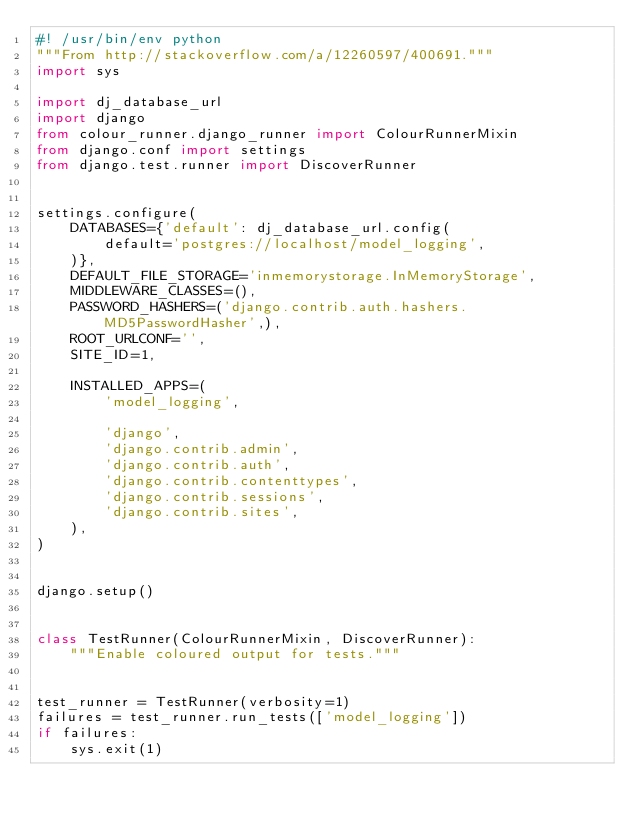Convert code to text. <code><loc_0><loc_0><loc_500><loc_500><_Python_>#! /usr/bin/env python
"""From http://stackoverflow.com/a/12260597/400691."""
import sys

import dj_database_url
import django
from colour_runner.django_runner import ColourRunnerMixin
from django.conf import settings
from django.test.runner import DiscoverRunner


settings.configure(
    DATABASES={'default': dj_database_url.config(
        default='postgres://localhost/model_logging',
    )},
    DEFAULT_FILE_STORAGE='inmemorystorage.InMemoryStorage',
    MIDDLEWARE_CLASSES=(),
    PASSWORD_HASHERS=('django.contrib.auth.hashers.MD5PasswordHasher',),
    ROOT_URLCONF='',
    SITE_ID=1,

    INSTALLED_APPS=(
        'model_logging',

        'django',
        'django.contrib.admin',
        'django.contrib.auth',
        'django.contrib.contenttypes',
        'django.contrib.sessions',
        'django.contrib.sites',
    ),
)


django.setup()


class TestRunner(ColourRunnerMixin, DiscoverRunner):
    """Enable coloured output for tests."""


test_runner = TestRunner(verbosity=1)
failures = test_runner.run_tests(['model_logging'])
if failures:
    sys.exit(1)
</code> 